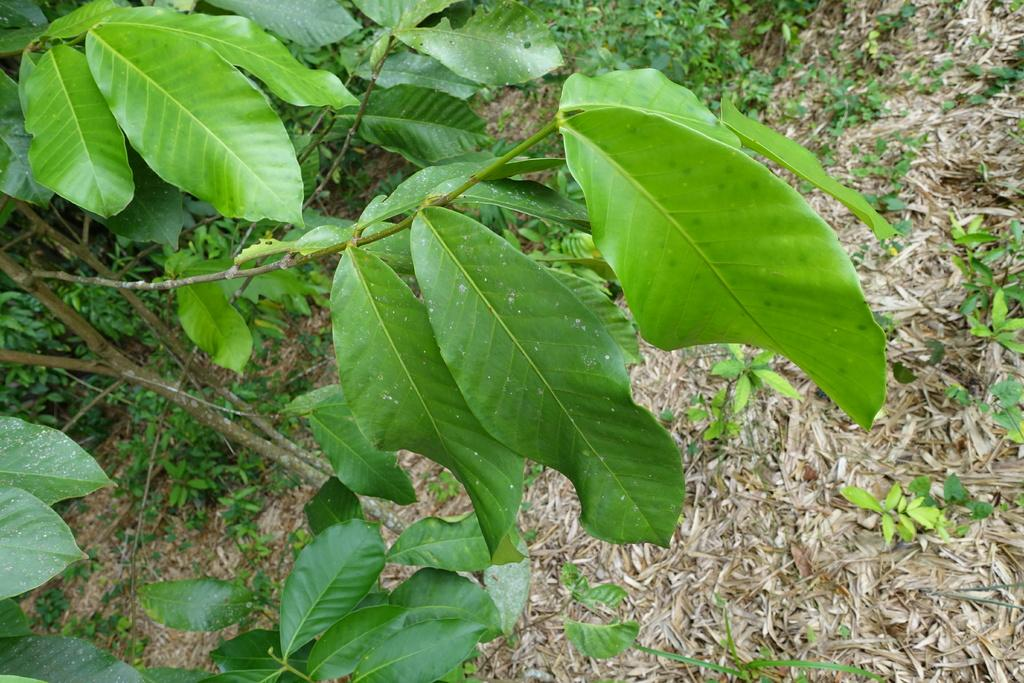Where was the image likely taken? The image was likely taken outside. What can be seen in the center of the image? There are green leaves and plants in the center of the image. What is the condition of the grass in the image? There is dry grass visible in the image. Can you describe any other objects in the image? There are other unspecified objects in the image. What type of toothpaste is being used to clean the leaves in the image? There is no toothpaste present in the image, and the leaves are not being cleaned. Can you describe the jewel that is hanging from the plant in the image? There is no jewel present in the image; only green leaves and plants are visible. 